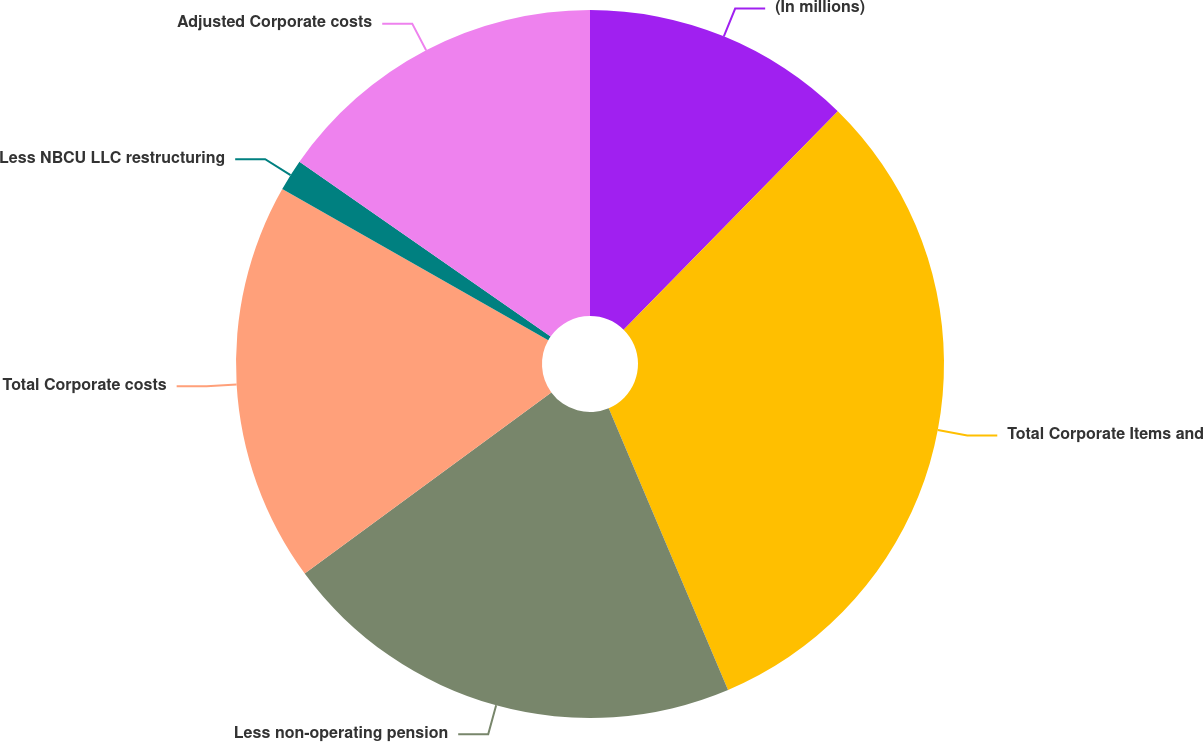Convert chart. <chart><loc_0><loc_0><loc_500><loc_500><pie_chart><fcel>(In millions)<fcel>Total Corporate Items and<fcel>Less non-operating pension<fcel>Total Corporate costs<fcel>Less NBCU LLC restructuring<fcel>Adjusted Corporate costs<nl><fcel>12.34%<fcel>31.28%<fcel>21.29%<fcel>18.31%<fcel>1.45%<fcel>15.32%<nl></chart> 